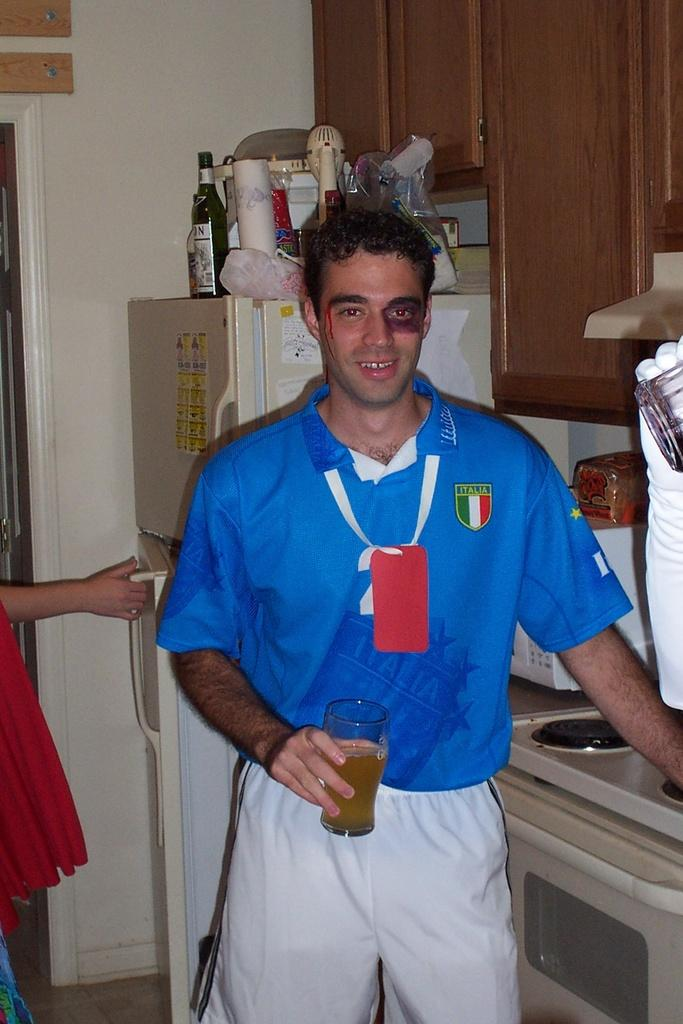Who is the main subject in the image? There is a man in the center of the image. What is the man holding in his hand? The man is holding a glass in his hand. What can be seen in the background of the image? There are cupboards, different items on a refrigerator, a lady, and a door in the background. How many glasses of water does the fifth person in the image have? There is no fifth person in the image, and the man in the image is holding only one glass. 